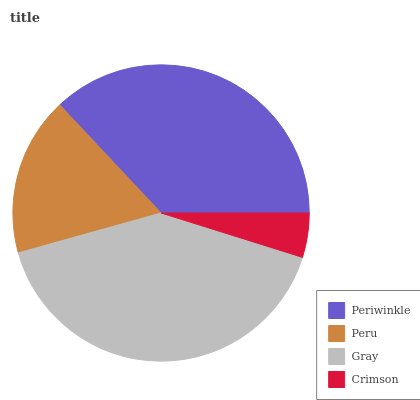Is Crimson the minimum?
Answer yes or no. Yes. Is Gray the maximum?
Answer yes or no. Yes. Is Peru the minimum?
Answer yes or no. No. Is Peru the maximum?
Answer yes or no. No. Is Periwinkle greater than Peru?
Answer yes or no. Yes. Is Peru less than Periwinkle?
Answer yes or no. Yes. Is Peru greater than Periwinkle?
Answer yes or no. No. Is Periwinkle less than Peru?
Answer yes or no. No. Is Periwinkle the high median?
Answer yes or no. Yes. Is Peru the low median?
Answer yes or no. Yes. Is Peru the high median?
Answer yes or no. No. Is Periwinkle the low median?
Answer yes or no. No. 